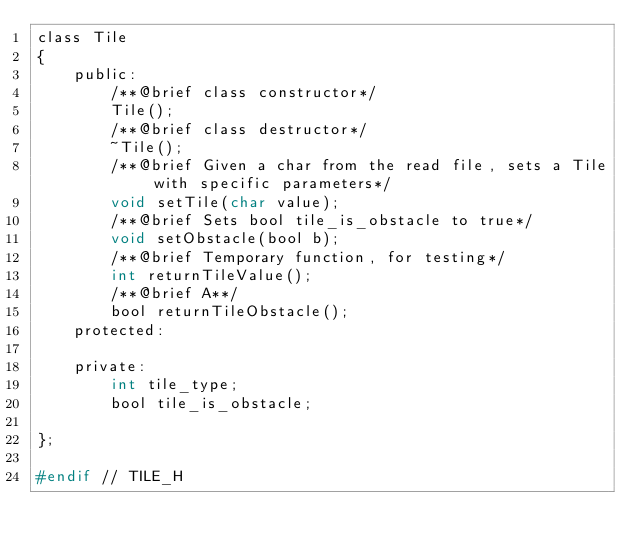Convert code to text. <code><loc_0><loc_0><loc_500><loc_500><_C_>class Tile
{
    public:
        /**@brief class constructor*/
        Tile();
        /**@brief class destructor*/
        ~Tile();
        /**@brief Given a char from the read file, sets a Tile with specific parameters*/
        void setTile(char value);
        /**@brief Sets bool tile_is_obstacle to true*/
        void setObstacle(bool b);
        /**@brief Temporary function, for testing*/
        int returnTileValue();
        /**@brief A**/
        bool returnTileObstacle();
    protected:

    private:
        int tile_type;
        bool tile_is_obstacle;

};

#endif // TILE_H
</code> 